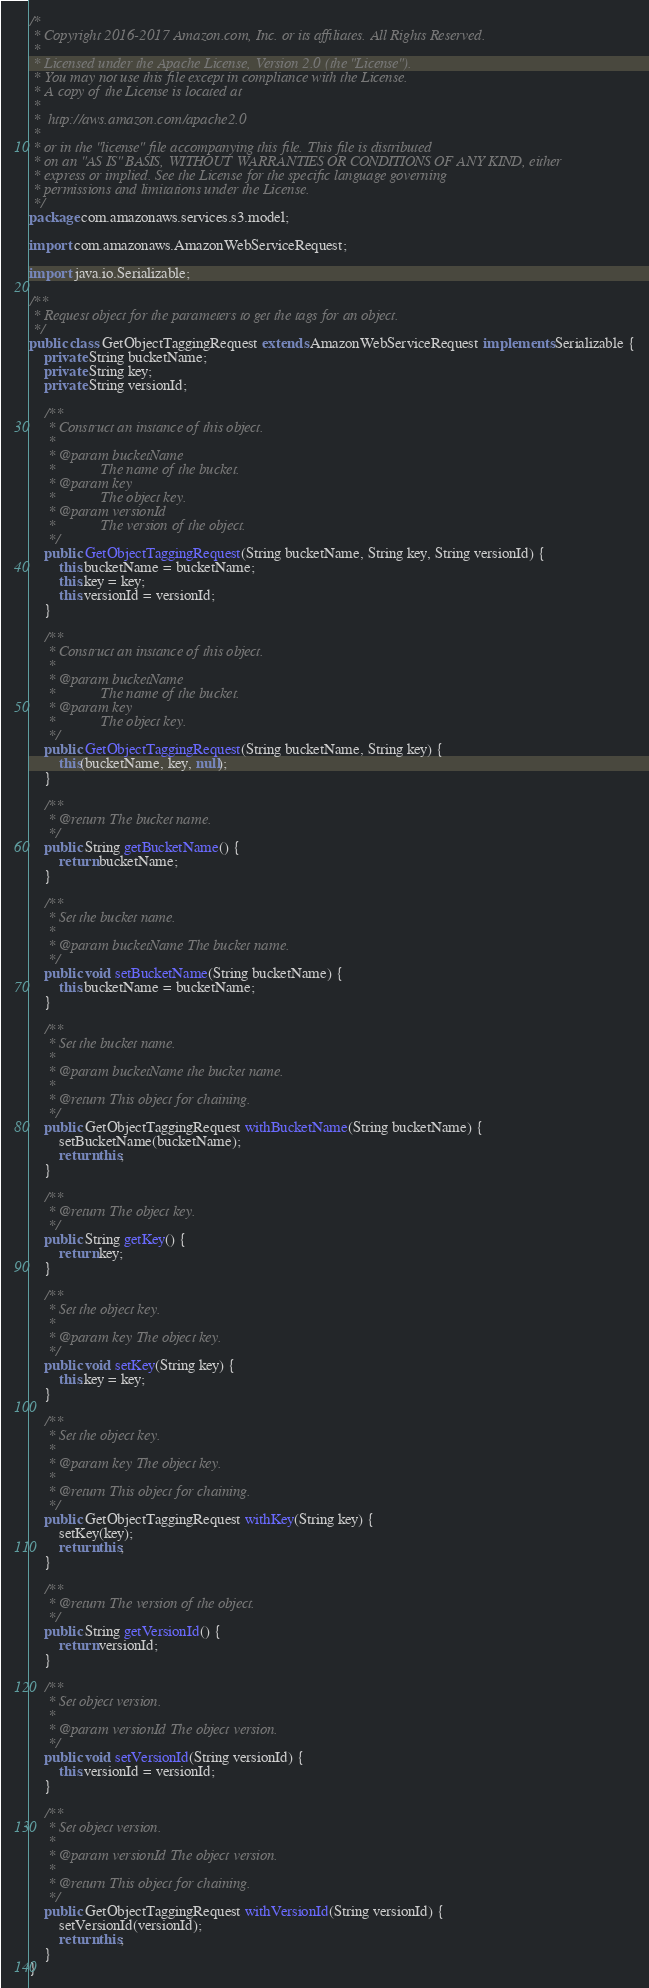<code> <loc_0><loc_0><loc_500><loc_500><_Java_>/*
 * Copyright 2016-2017 Amazon.com, Inc. or its affiliates. All Rights Reserved.
 *
 * Licensed under the Apache License, Version 2.0 (the "License").
 * You may not use this file except in compliance with the License.
 * A copy of the License is located at
 *
 *  http://aws.amazon.com/apache2.0
 *
 * or in the "license" file accompanying this file. This file is distributed
 * on an "AS IS" BASIS, WITHOUT WARRANTIES OR CONDITIONS OF ANY KIND, either
 * express or implied. See the License for the specific language governing
 * permissions and limitations under the License.
 */
package com.amazonaws.services.s3.model;

import com.amazonaws.AmazonWebServiceRequest;

import java.io.Serializable;

/**
 * Request object for the parameters to get the tags for an object.
 */
public class GetObjectTaggingRequest extends AmazonWebServiceRequest implements Serializable {
    private String bucketName;
    private String key;
    private String versionId;

    /**
     * Construct an instance of this object.
     *
     * @param bucketName
     *            The name of the bucket.
     * @param key
     *            The object key.
     * @param versionId
     *            The version of the object.
     */
    public GetObjectTaggingRequest(String bucketName, String key, String versionId) {
        this.bucketName = bucketName;
        this.key = key;
        this.versionId = versionId;
    }

    /**
     * Construct an instance of this object.
     *
     * @param bucketName
     *            The name of the bucket.
     * @param key
     *            The object key.
     */
    public GetObjectTaggingRequest(String bucketName, String key) {
        this(bucketName, key, null);
    }

    /**
     * @return The bucket name.
     */
    public String getBucketName() {
        return bucketName;
    }

    /**
     * Set the bucket name.
     *
     * @param bucketName The bucket name.
     */
    public void setBucketName(String bucketName) {
        this.bucketName = bucketName;
    }

    /**
     * Set the bucket name.
     *
     * @param bucketName the bucket name.
     *
     * @return This object for chaining.
     */
    public GetObjectTaggingRequest withBucketName(String bucketName) {
        setBucketName(bucketName);
        return this;
    }

    /**
     * @return The object key.
     */
    public String getKey() {
        return key;
    }

    /**
     * Set the object key.
     *
     * @param key The object key.
     */
    public void setKey(String key) {
        this.key = key;
    }

    /**
     * Set the object key.
     *
     * @param key The object key.
     *
     * @return This object for chaining.
     */
    public GetObjectTaggingRequest withKey(String key) {
        setKey(key);
        return this;
    }

    /**
     * @return The version of the object.
     */
    public String getVersionId() {
        return versionId;
    }

    /**
     * Set object version.
     *
     * @param versionId The object version.
     */
    public void setVersionId(String versionId) {
        this.versionId = versionId;
    }

    /**
     * Set object version.
     *
     * @param versionId The object version.
     *
     * @return This object for chaining.
     */
    public GetObjectTaggingRequest withVersionId(String versionId) {
        setVersionId(versionId);
        return this;
    }
}
</code> 